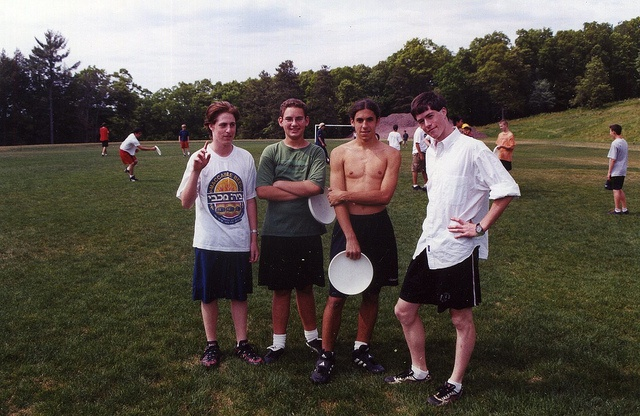Describe the objects in this image and their specific colors. I can see people in ivory, lightgray, black, darkgray, and brown tones, people in white, black, brown, maroon, and salmon tones, people in ivory, black, darkgray, maroon, and lightgray tones, people in white, black, maroon, gray, and brown tones, and frisbee in white, darkgray, lightgray, and gray tones in this image. 